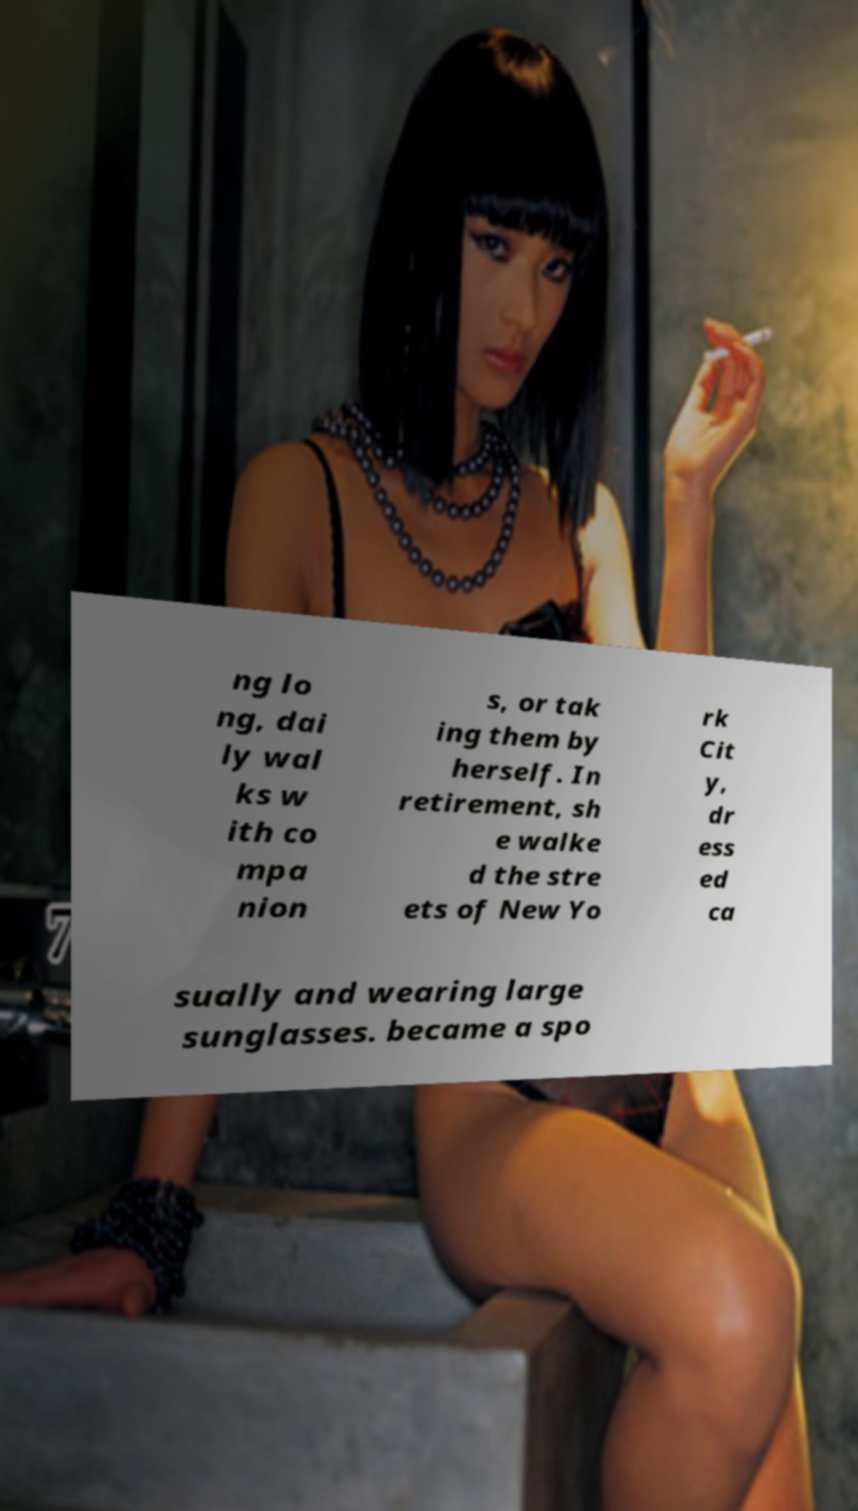Could you extract and type out the text from this image? ng lo ng, dai ly wal ks w ith co mpa nion s, or tak ing them by herself. In retirement, sh e walke d the stre ets of New Yo rk Cit y, dr ess ed ca sually and wearing large sunglasses. became a spo 